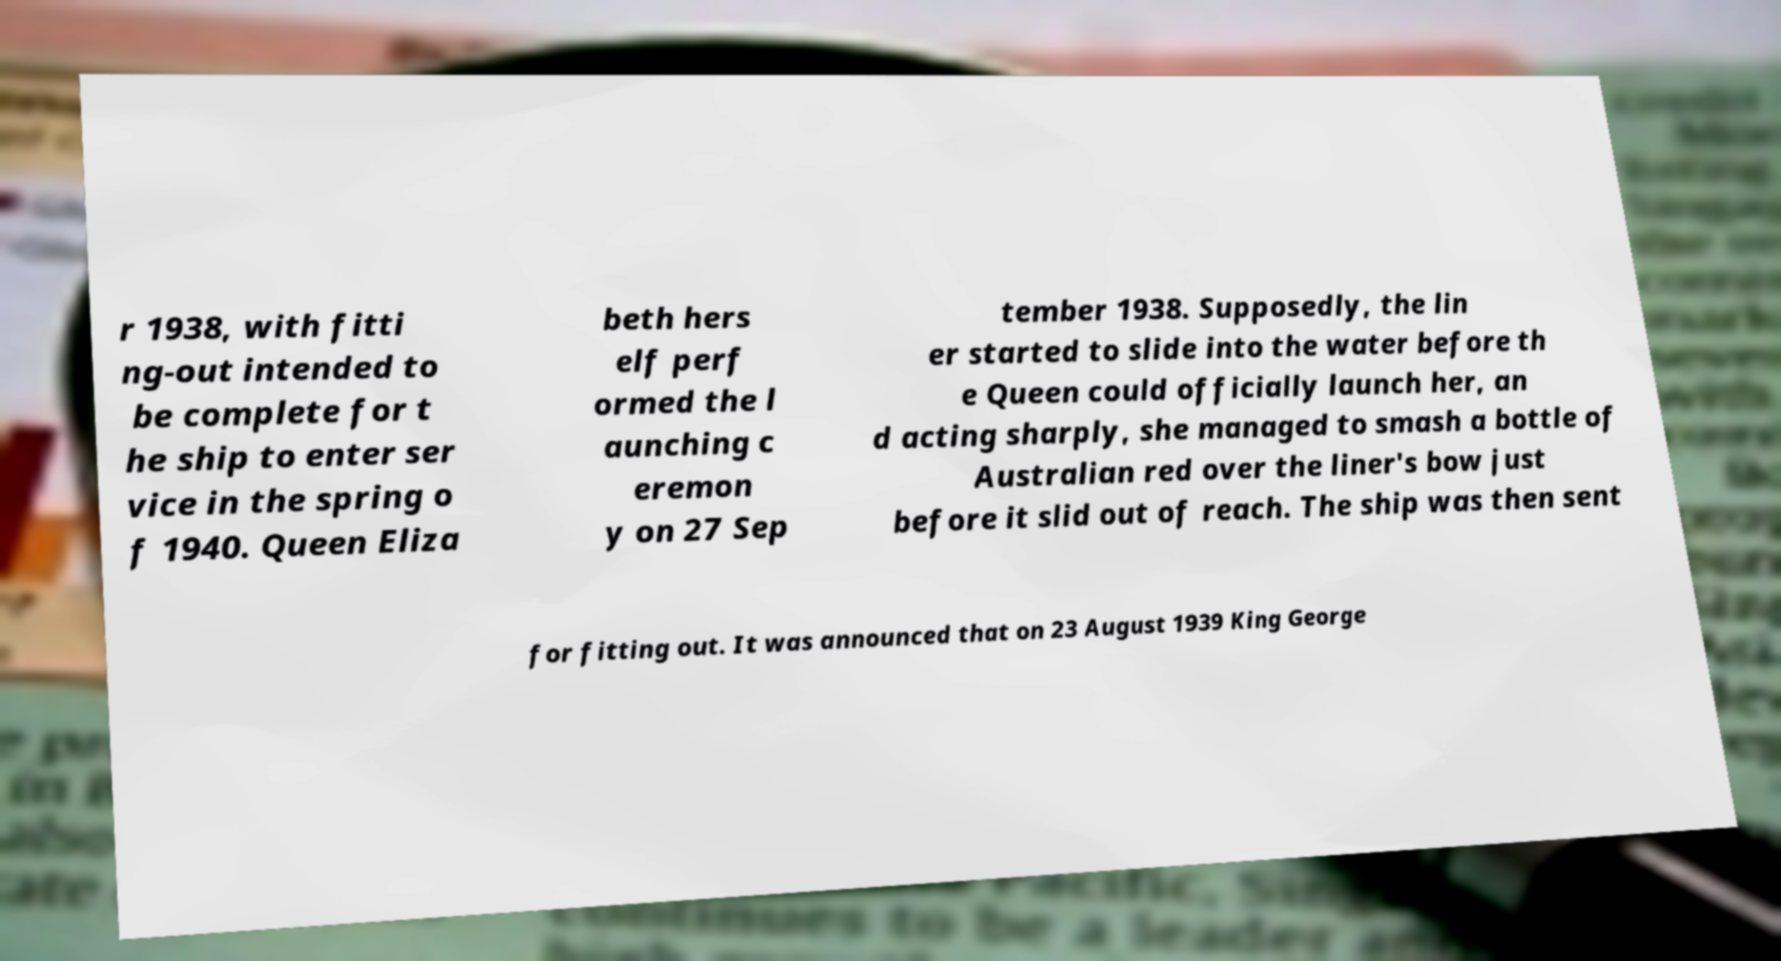Please read and relay the text visible in this image. What does it say? r 1938, with fitti ng-out intended to be complete for t he ship to enter ser vice in the spring o f 1940. Queen Eliza beth hers elf perf ormed the l aunching c eremon y on 27 Sep tember 1938. Supposedly, the lin er started to slide into the water before th e Queen could officially launch her, an d acting sharply, she managed to smash a bottle of Australian red over the liner's bow just before it slid out of reach. The ship was then sent for fitting out. It was announced that on 23 August 1939 King George 